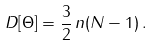Convert formula to latex. <formula><loc_0><loc_0><loc_500><loc_500>D [ \Theta ] = \frac { 3 } { 2 } \, n ( N - 1 ) \, .</formula> 